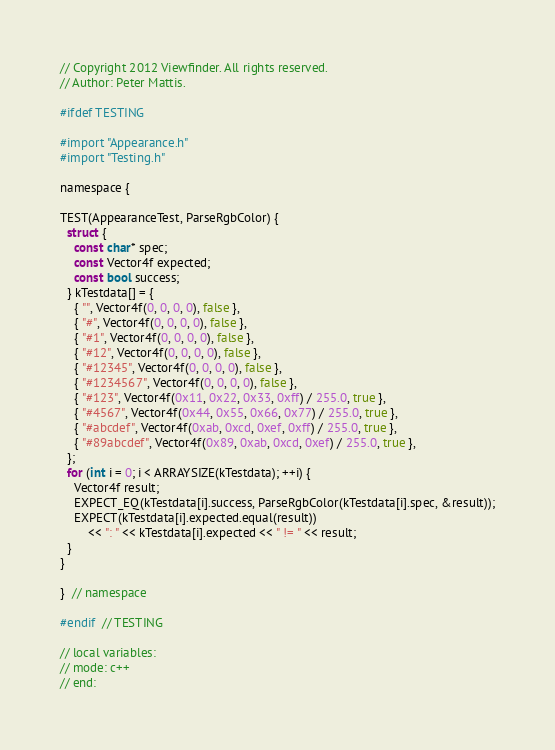<code> <loc_0><loc_0><loc_500><loc_500><_ObjectiveC_>// Copyright 2012 Viewfinder. All rights reserved.
// Author: Peter Mattis.

#ifdef TESTING

#import "Appearance.h"
#import "Testing.h"

namespace {

TEST(AppearanceTest, ParseRgbColor) {
  struct {
    const char* spec;
    const Vector4f expected;
    const bool success;
  } kTestdata[] = {
    { "", Vector4f(0, 0, 0, 0), false },
    { "#", Vector4f(0, 0, 0, 0), false },
    { "#1", Vector4f(0, 0, 0, 0), false },
    { "#12", Vector4f(0, 0, 0, 0), false },
    { "#12345", Vector4f(0, 0, 0, 0), false },
    { "#1234567", Vector4f(0, 0, 0, 0), false },
    { "#123", Vector4f(0x11, 0x22, 0x33, 0xff) / 255.0, true },
    { "#4567", Vector4f(0x44, 0x55, 0x66, 0x77) / 255.0, true },
    { "#abcdef", Vector4f(0xab, 0xcd, 0xef, 0xff) / 255.0, true },
    { "#89abcdef", Vector4f(0x89, 0xab, 0xcd, 0xef) / 255.0, true },
  };
  for (int i = 0; i < ARRAYSIZE(kTestdata); ++i) {
    Vector4f result;
    EXPECT_EQ(kTestdata[i].success, ParseRgbColor(kTestdata[i].spec, &result));
    EXPECT(kTestdata[i].expected.equal(result))
        << ": " << kTestdata[i].expected << " != " << result;
  }
}

}  // namespace

#endif  // TESTING

// local variables:
// mode: c++
// end:
</code> 